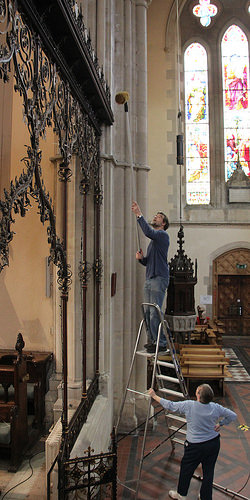<image>
Is the man above the woman? Yes. The man is positioned above the woman in the vertical space, higher up in the scene. 